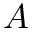<formula> <loc_0><loc_0><loc_500><loc_500>A</formula> 